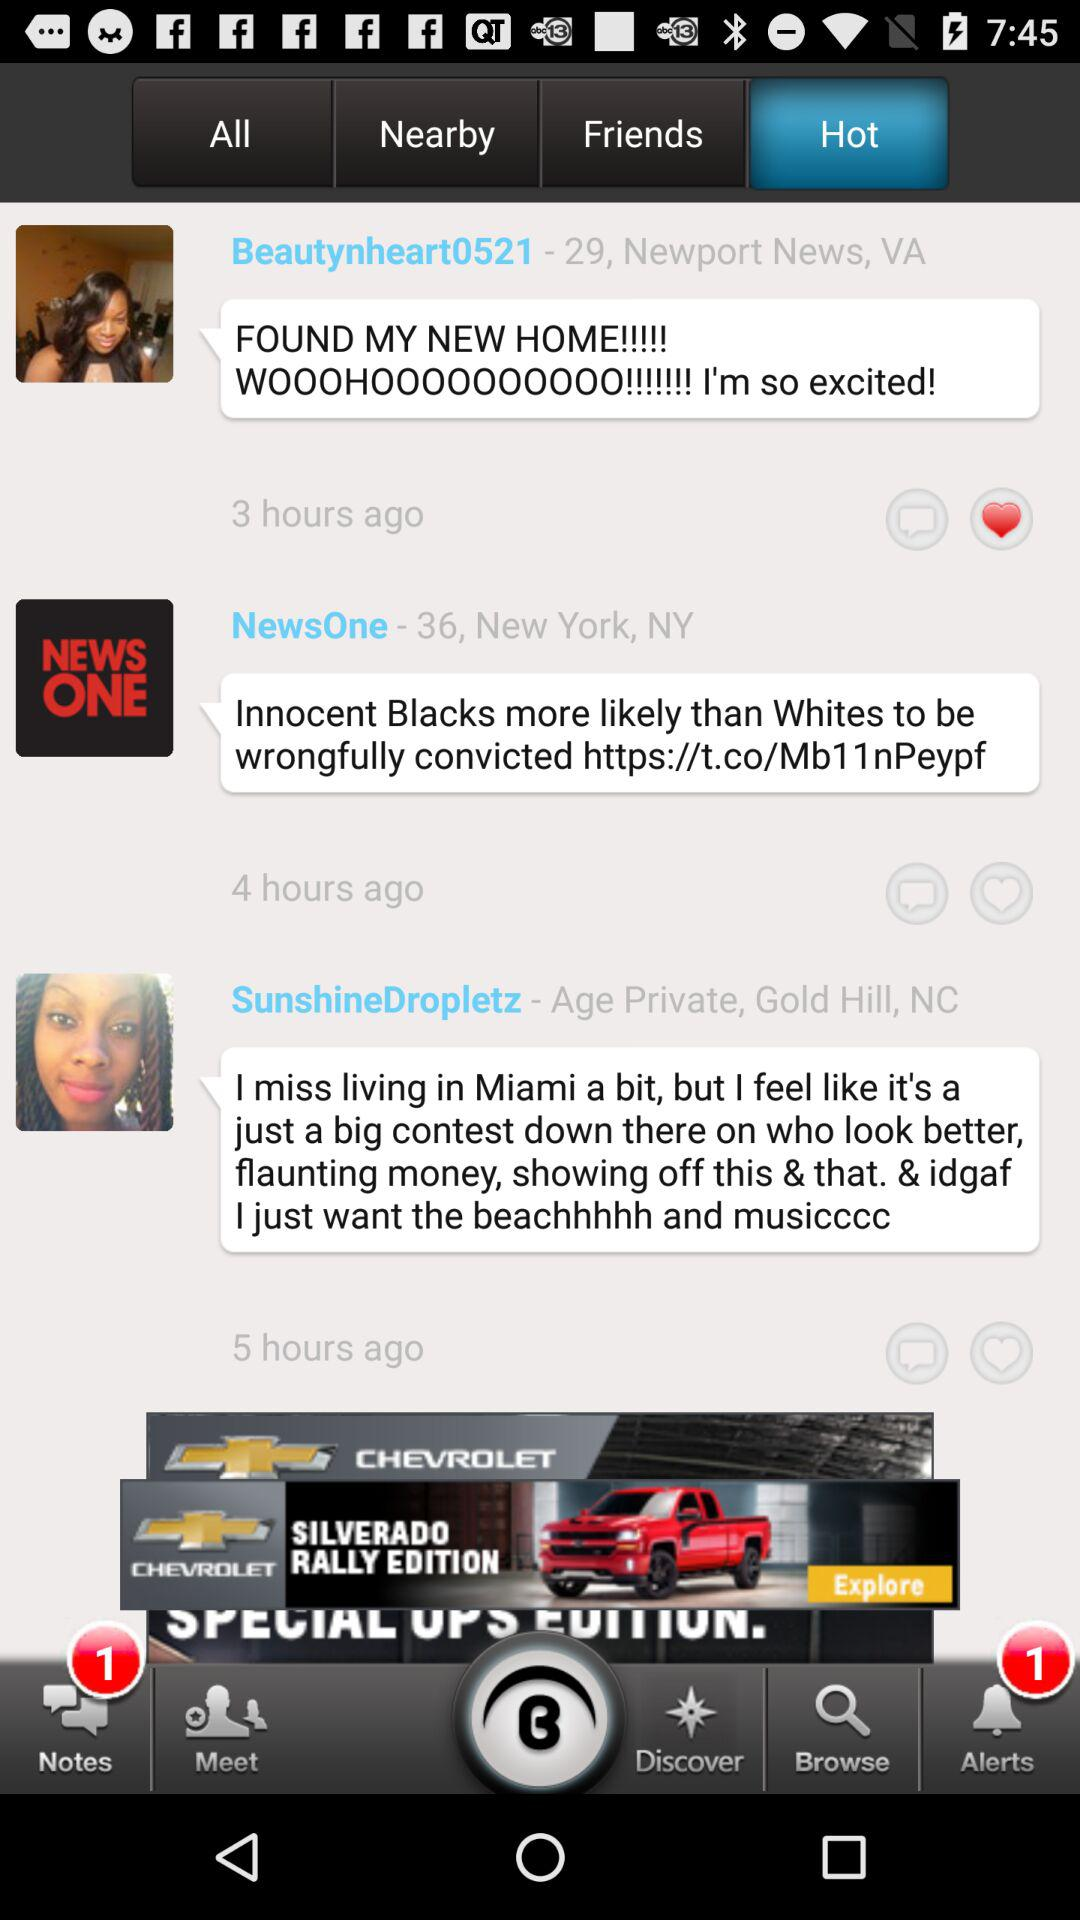How long ago was the comment by "Beautynheart0521" posted? The comment was posted 3 hours ago. 